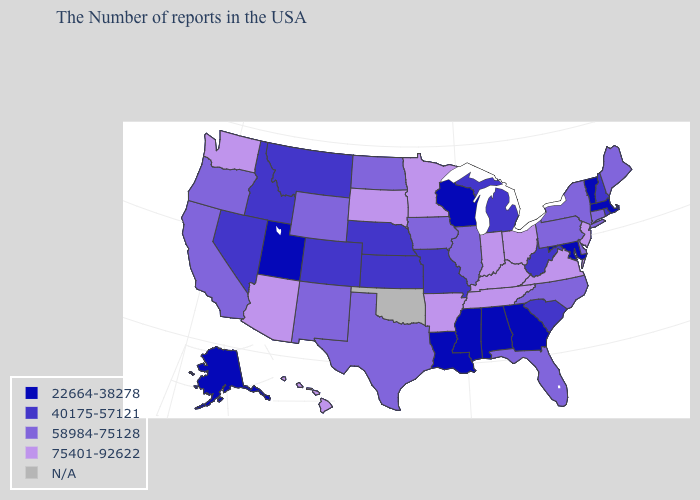What is the value of Oklahoma?
Answer briefly. N/A. What is the value of Arizona?
Short answer required. 75401-92622. Name the states that have a value in the range 22664-38278?
Give a very brief answer. Massachusetts, Vermont, Maryland, Georgia, Alabama, Wisconsin, Mississippi, Louisiana, Utah, Alaska. What is the value of Oregon?
Short answer required. 58984-75128. Among the states that border North Carolina , does Virginia have the lowest value?
Be succinct. No. What is the value of Utah?
Answer briefly. 22664-38278. Name the states that have a value in the range 58984-75128?
Keep it brief. Maine, Connecticut, New York, Delaware, Pennsylvania, North Carolina, Florida, Illinois, Iowa, Texas, North Dakota, Wyoming, New Mexico, California, Oregon. Name the states that have a value in the range 58984-75128?
Concise answer only. Maine, Connecticut, New York, Delaware, Pennsylvania, North Carolina, Florida, Illinois, Iowa, Texas, North Dakota, Wyoming, New Mexico, California, Oregon. Name the states that have a value in the range 75401-92622?
Quick response, please. New Jersey, Virginia, Ohio, Kentucky, Indiana, Tennessee, Arkansas, Minnesota, South Dakota, Arizona, Washington, Hawaii. What is the lowest value in the USA?
Concise answer only. 22664-38278. Name the states that have a value in the range 40175-57121?
Answer briefly. Rhode Island, New Hampshire, South Carolina, West Virginia, Michigan, Missouri, Kansas, Nebraska, Colorado, Montana, Idaho, Nevada. Among the states that border Utah , does Nevada have the lowest value?
Quick response, please. Yes. How many symbols are there in the legend?
Answer briefly. 5. Name the states that have a value in the range 22664-38278?
Be succinct. Massachusetts, Vermont, Maryland, Georgia, Alabama, Wisconsin, Mississippi, Louisiana, Utah, Alaska. 